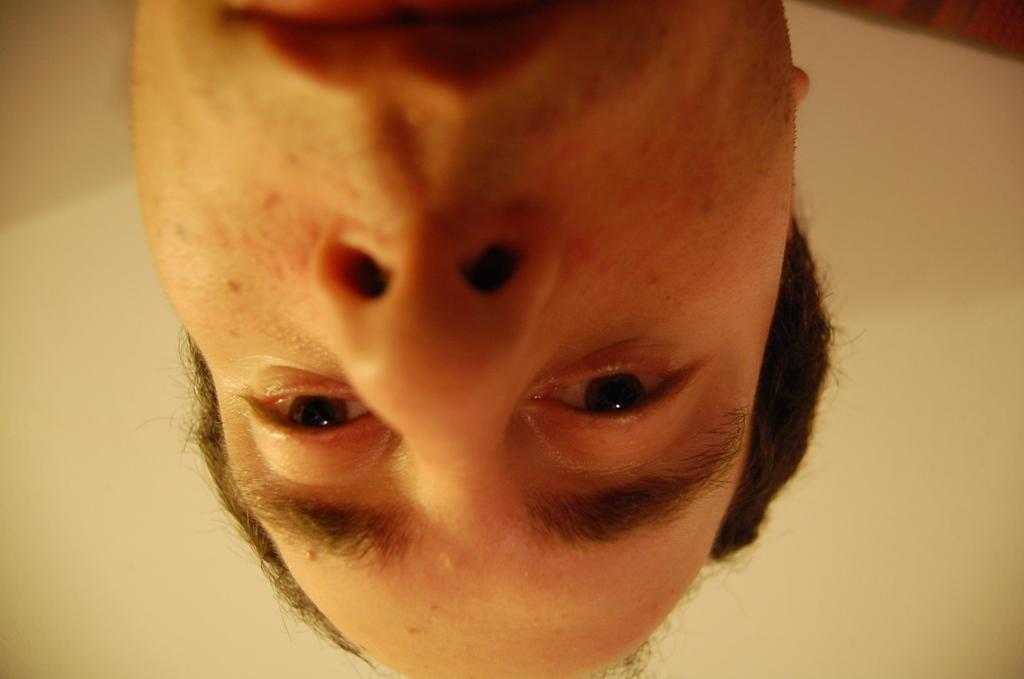What is the main subject in the center of the image? There is a human face in the center of the image. What can be seen in the background of the image? There is a wall in the background of the image. What hobbies does the achiever have in the image? There is no reference to an achiever or any hobbies in the image, as it only features a human face and a wall in the background. 